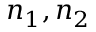Convert formula to latex. <formula><loc_0><loc_0><loc_500><loc_500>n _ { 1 } , n _ { 2 }</formula> 